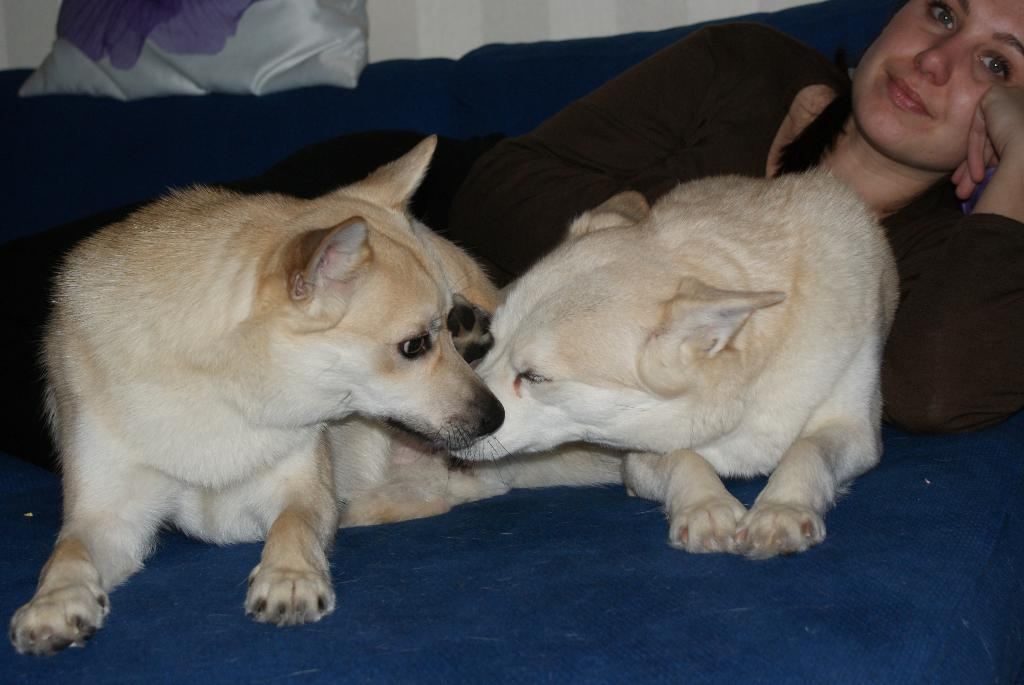What is the woman doing in the image? The woman is laying on a blue surface. What animals are present in the image? There are two dogs in front of the woman. What can be seen in the background of the image? There is a pillow and a wall in the background. What type of leather is covering the tomatoes in the image? There are no tomatoes or leather present in the image. 